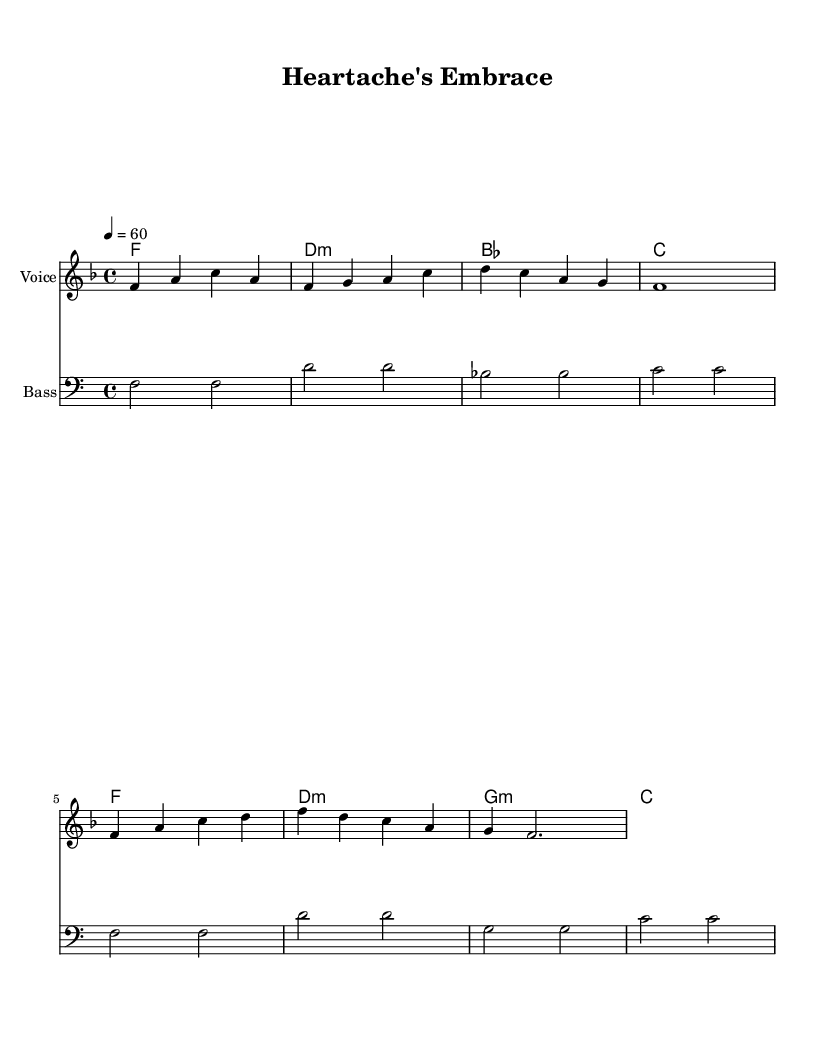What is the key signature of this music? The key signature is F major, which has one flat (B♭). You can find the key signature indicated at the beginning of the sheet music, showing the B♭ note.
Answer: F major What is the time signature of this piece? The time signature is 4/4, as indicated at the beginning of the staff. This means there are four beats in each measure and a quarter note receives one beat.
Answer: 4/4 What is the tempo marking for this music? The tempo marking is 60 beats per minute, illustrated by "4 = 60" at the start of the sheet music, indicating that each quarter note should be played at this speed.
Answer: 60 How many measures are there in the melody? The melody consists of 8 measures, which can be counted by observing the division of the music into sections and the number of distinct groups of beats.
Answer: 8 What type of chords are used in the harmonies? The harmonies primarily use major and minor chords, identified by the symbols such as "f" for F major and "d:m" for D minor in the chord names section.
Answer: Major and minor Are there any vocal dynamics indicated in the melody? There are no specific dynamics indicated in the melody section of the music, as it appears simple and straightforward without markings for loudness or softness.
Answer: None 